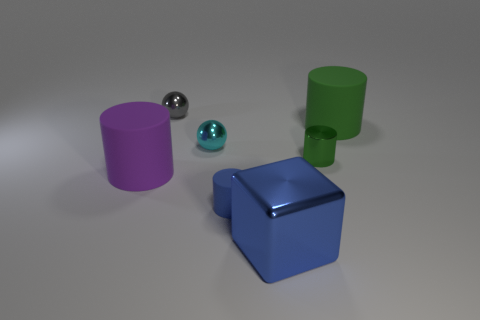There is another tiny object that is the same shape as the gray thing; what is it made of?
Your answer should be very brief. Metal. What number of balls are either big green things or cyan rubber objects?
Offer a terse response. 0. There is a metallic object on the right side of the big metallic thing; is its size the same as the sphere that is right of the tiny gray ball?
Give a very brief answer. Yes. What material is the object that is behind the rubber cylinder on the right side of the large blue thing?
Provide a succinct answer. Metal. Are there fewer tiny gray objects in front of the purple cylinder than big yellow metallic things?
Keep it short and to the point. No. There is a tiny cyan object that is made of the same material as the large cube; what is its shape?
Keep it short and to the point. Sphere. How many other objects are there of the same shape as the small green shiny object?
Provide a succinct answer. 3. How many yellow objects are metal things or blocks?
Your answer should be very brief. 0. Is the shape of the large metallic thing the same as the gray object?
Your response must be concise. No. There is a rubber cylinder on the left side of the small cyan object; are there any big purple matte cylinders on the right side of it?
Your answer should be compact. No. 